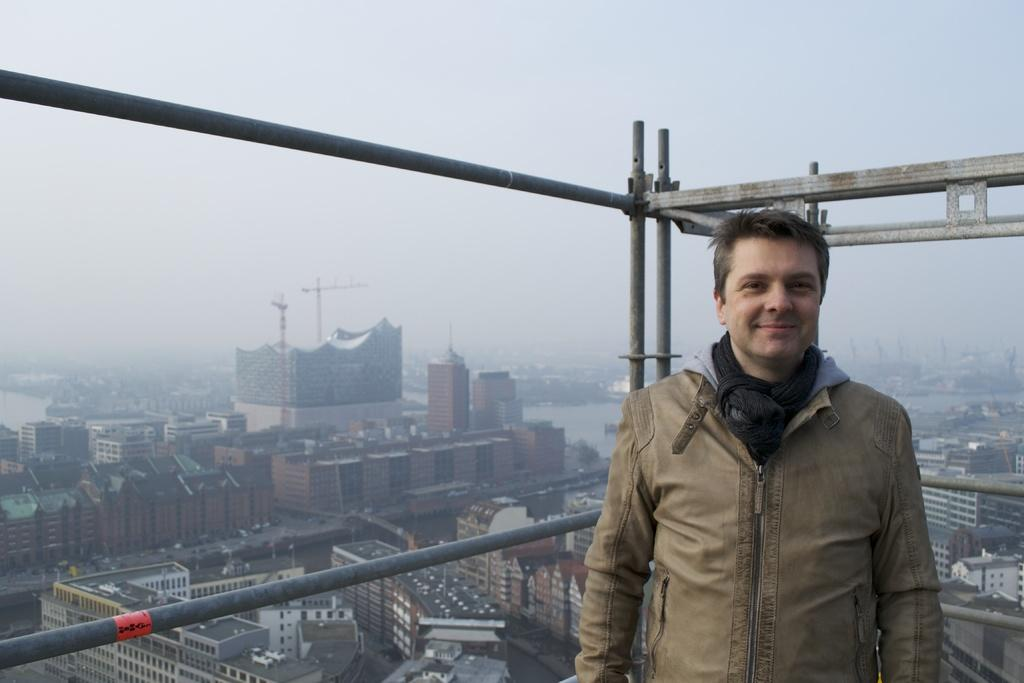Who is present in the image? There is a man in the image. What is the man's facial expression? The man is smiling. What can be seen behind the man? There are poles visible behind the man. What is visible in the background of the image? There are buildings and the sky in the background of the image. What type of pear is hanging from the branch in the image? There is no pear or branch present in the image. What is the zinc content of the buildings in the background? The zinc content of the buildings cannot be determined from the image. 